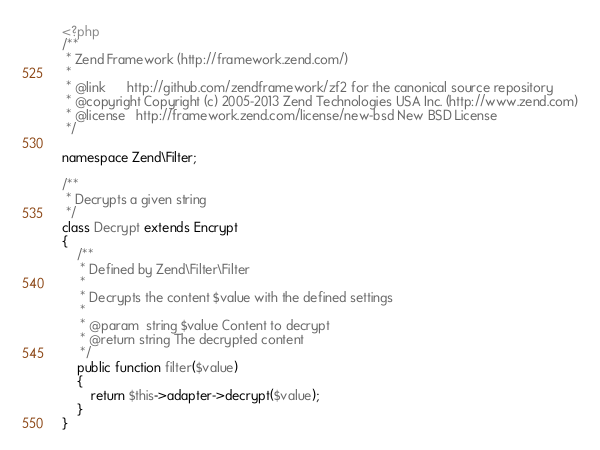Convert code to text. <code><loc_0><loc_0><loc_500><loc_500><_PHP_><?php
/**
 * Zend Framework (http://framework.zend.com/)
 *
 * @link      http://github.com/zendframework/zf2 for the canonical source repository
 * @copyright Copyright (c) 2005-2013 Zend Technologies USA Inc. (http://www.zend.com)
 * @license   http://framework.zend.com/license/new-bsd New BSD License
 */

namespace Zend\Filter;

/**
 * Decrypts a given string
 */
class Decrypt extends Encrypt
{
    /**
     * Defined by Zend\Filter\Filter
     *
     * Decrypts the content $value with the defined settings
     *
     * @param  string $value Content to decrypt
     * @return string The decrypted content
     */
    public function filter($value)
    {
        return $this->adapter->decrypt($value);
    }
}
</code> 